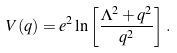Convert formula to latex. <formula><loc_0><loc_0><loc_500><loc_500>V ( q ) = e ^ { 2 } \ln \left [ \frac { \Lambda ^ { 2 } + q ^ { 2 } } { q ^ { 2 } } \right ] \, .</formula> 